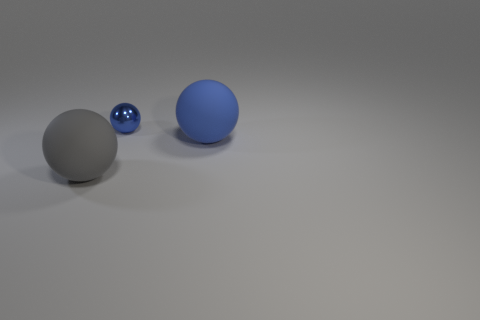Subtract all tiny blue spheres. How many spheres are left? 2 Add 1 purple things. How many objects exist? 4 Subtract all blue cylinders. How many blue balls are left? 2 Subtract 2 balls. How many balls are left? 1 Subtract all gray spheres. How many spheres are left? 2 Add 1 small green rubber spheres. How many small green rubber spheres exist? 1 Subtract 0 blue cylinders. How many objects are left? 3 Subtract all cyan balls. Subtract all brown blocks. How many balls are left? 3 Subtract all purple matte balls. Subtract all metallic balls. How many objects are left? 2 Add 1 blue metallic balls. How many blue metallic balls are left? 2 